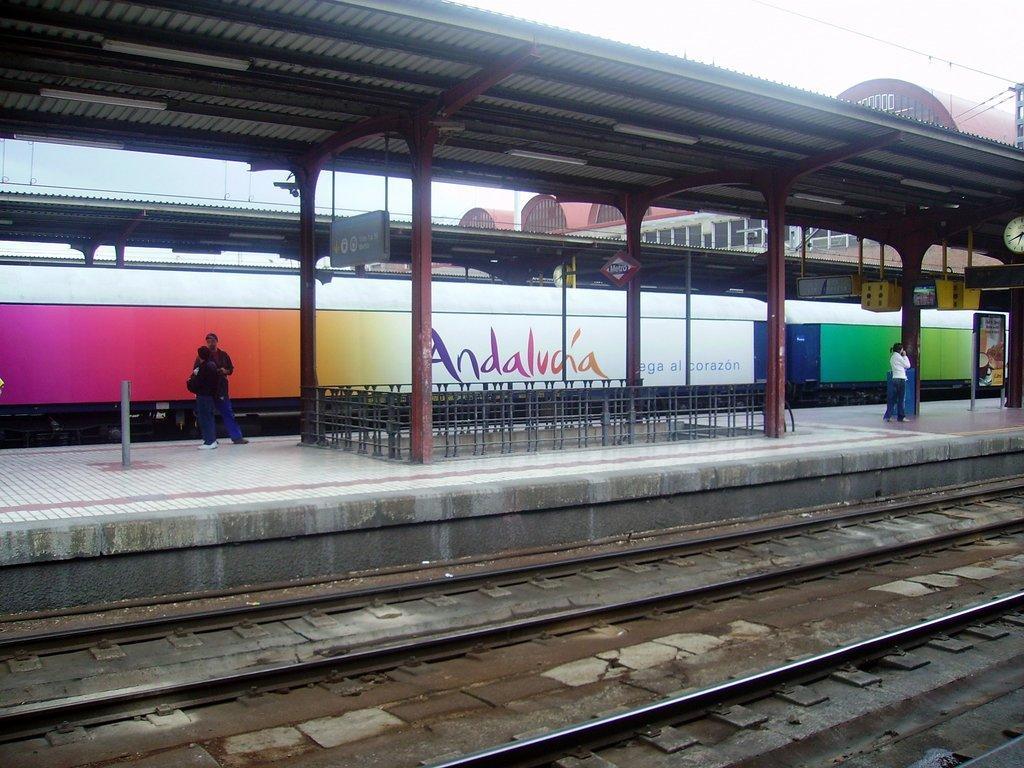How would you summarize this image in a sentence or two? In this picture we can see people standing in front of a train on the railway platform made with iron roof and pillars. At the bottom we can see railway tracks and at the top we can see the poles, wires and buildings. 